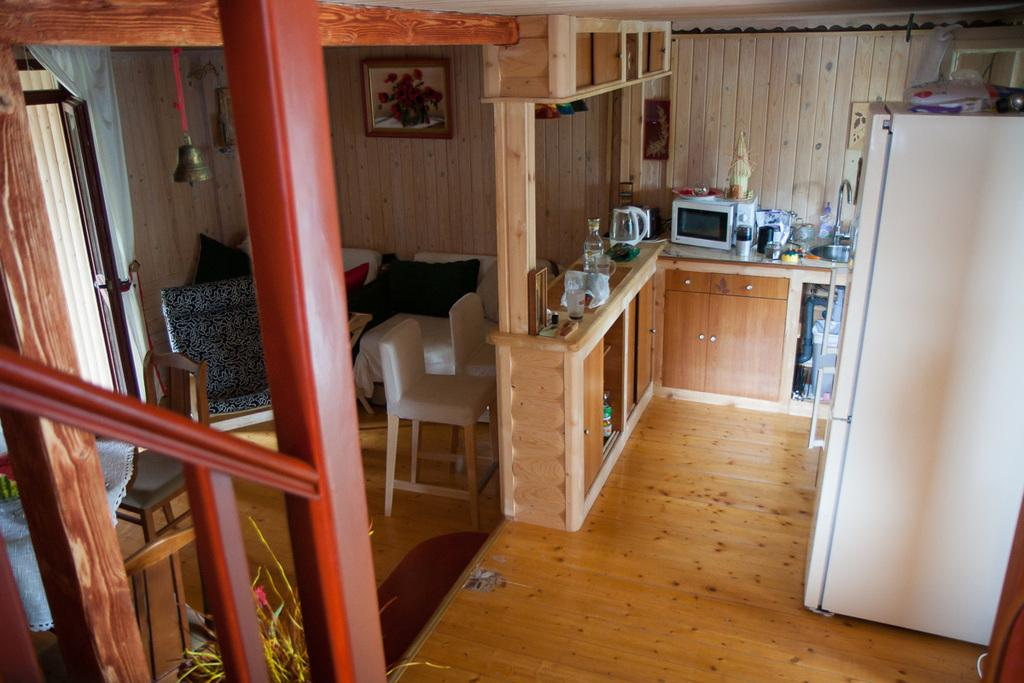What type of location is depicted in the image? The image shows an inner view of a house. What appliance can be seen in the image? There is a refrigerator in the image. What objects are visible that might be used for cooking or storing food? There are vessels and a microwave oven on the countertop visible in the image. What type of furniture is present in the image? There are chairs in the image. What decorative item can be seen hanging in the image? There is a bell hanging in the image. What type of engine can be seen powering the refrigerator in the image? There is no engine visible in the image, as refrigerators do not have visible engines. The refrigerator is powered by electricity, which is not visible in the image. What type of birds are flying around the bell in the image? There are no birds present in the image; the only visible objects are the house interior, appliances, and furniture. 